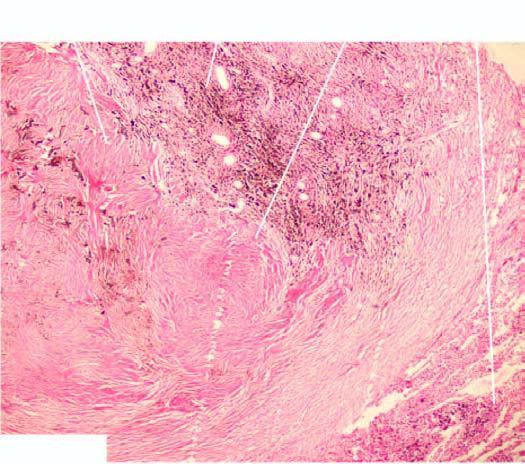re coal macules composed of aggregates of dust-laden macrophages and collagens seen surrounding respiratory bronchioles?
Answer the question using a single word or phrase. Yes 